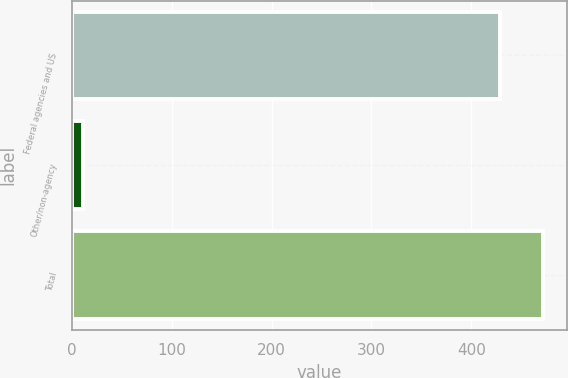Convert chart to OTSL. <chart><loc_0><loc_0><loc_500><loc_500><bar_chart><fcel>Federal agencies and US<fcel>Other/non-agency<fcel>Total<nl><fcel>429<fcel>11<fcel>471.9<nl></chart> 